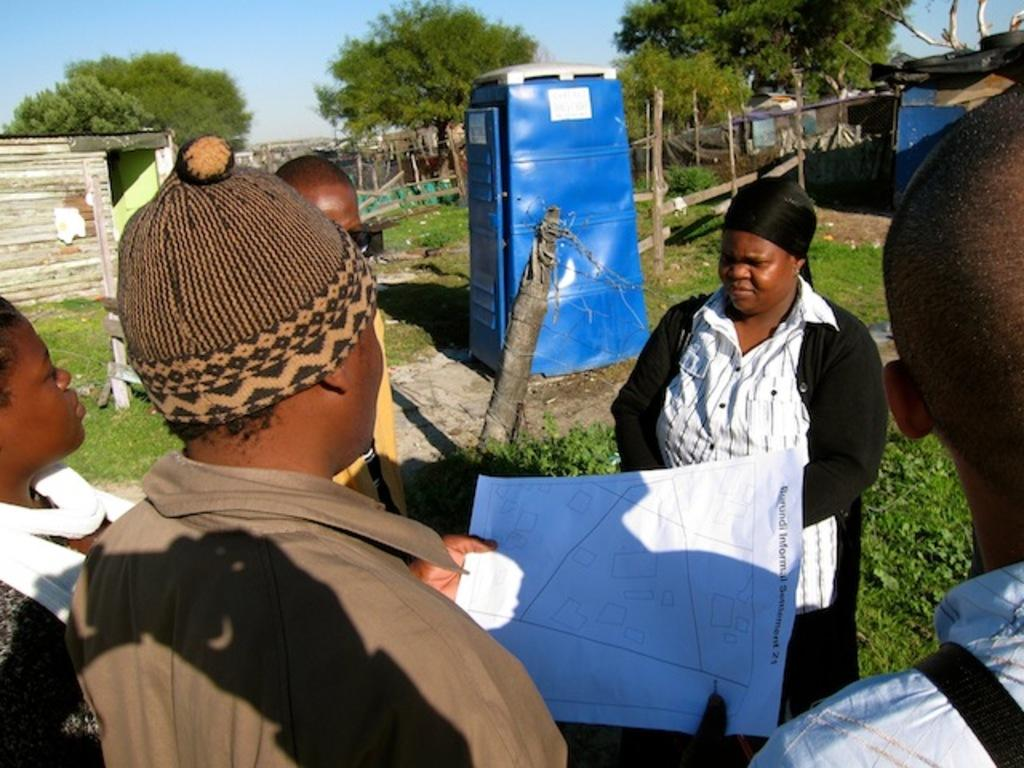What can be seen in the foreground of the image? There are people in the foreground of the image. What is one person doing in the image? One person is holding a paper. What type of structure is visible in the background of the image? There is a cabin in the background of the image. What other elements can be seen in the background of the image? There are trees, buildings, and a boundary visible in the background of the image. What is the condition of the sky in the image? The sky is clear in the image. What type of roll can be seen in the image? There is no roll present in the image. What kind of band is playing in the background of the image? There is no band present in the image. 